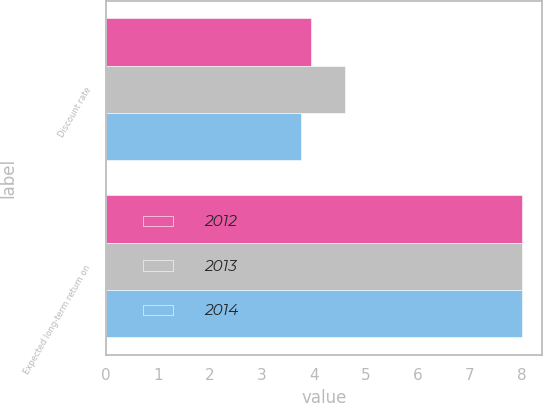Convert chart to OTSL. <chart><loc_0><loc_0><loc_500><loc_500><stacked_bar_chart><ecel><fcel>Discount rate<fcel>Expected long-term return on<nl><fcel>2012<fcel>3.95<fcel>8<nl><fcel>2013<fcel>4.6<fcel>8<nl><fcel>2014<fcel>3.75<fcel>8<nl></chart> 